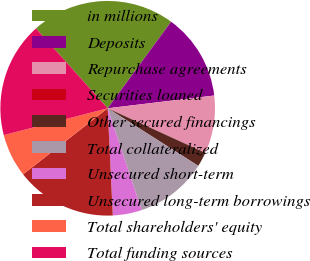Convert chart to OTSL. <chart><loc_0><loc_0><loc_500><loc_500><pie_chart><fcel>in millions<fcel>Deposits<fcel>Repurchase agreements<fcel>Securities loaned<fcel>Other secured financings<fcel>Total collateralized<fcel>Unsecured short-term<fcel>Unsecured long-term borrowings<fcel>Total shareholders' equity<fcel>Total funding sources<nl><fcel>21.71%<fcel>13.04%<fcel>8.7%<fcel>0.02%<fcel>2.19%<fcel>10.87%<fcel>4.36%<fcel>15.21%<fcel>6.53%<fcel>17.38%<nl></chart> 